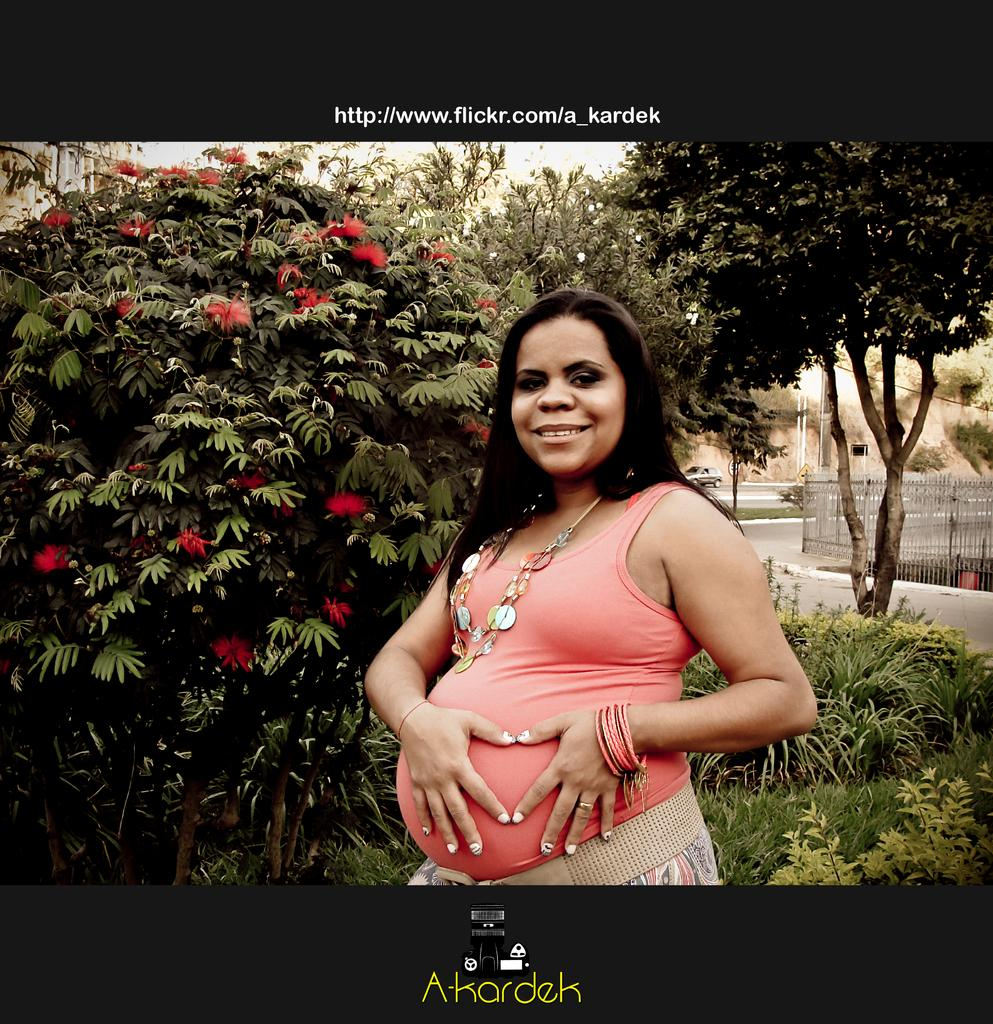Who is present in the image? There is a woman in the image. What is the woman's expression? The woman is smiling. What can be seen in the background of the image? There is a fence, trees, and a car on the road in the background of the image. What type of stamp can be seen on the woman's forehead in the image? There is no stamp present on the woman's forehead in the image. 